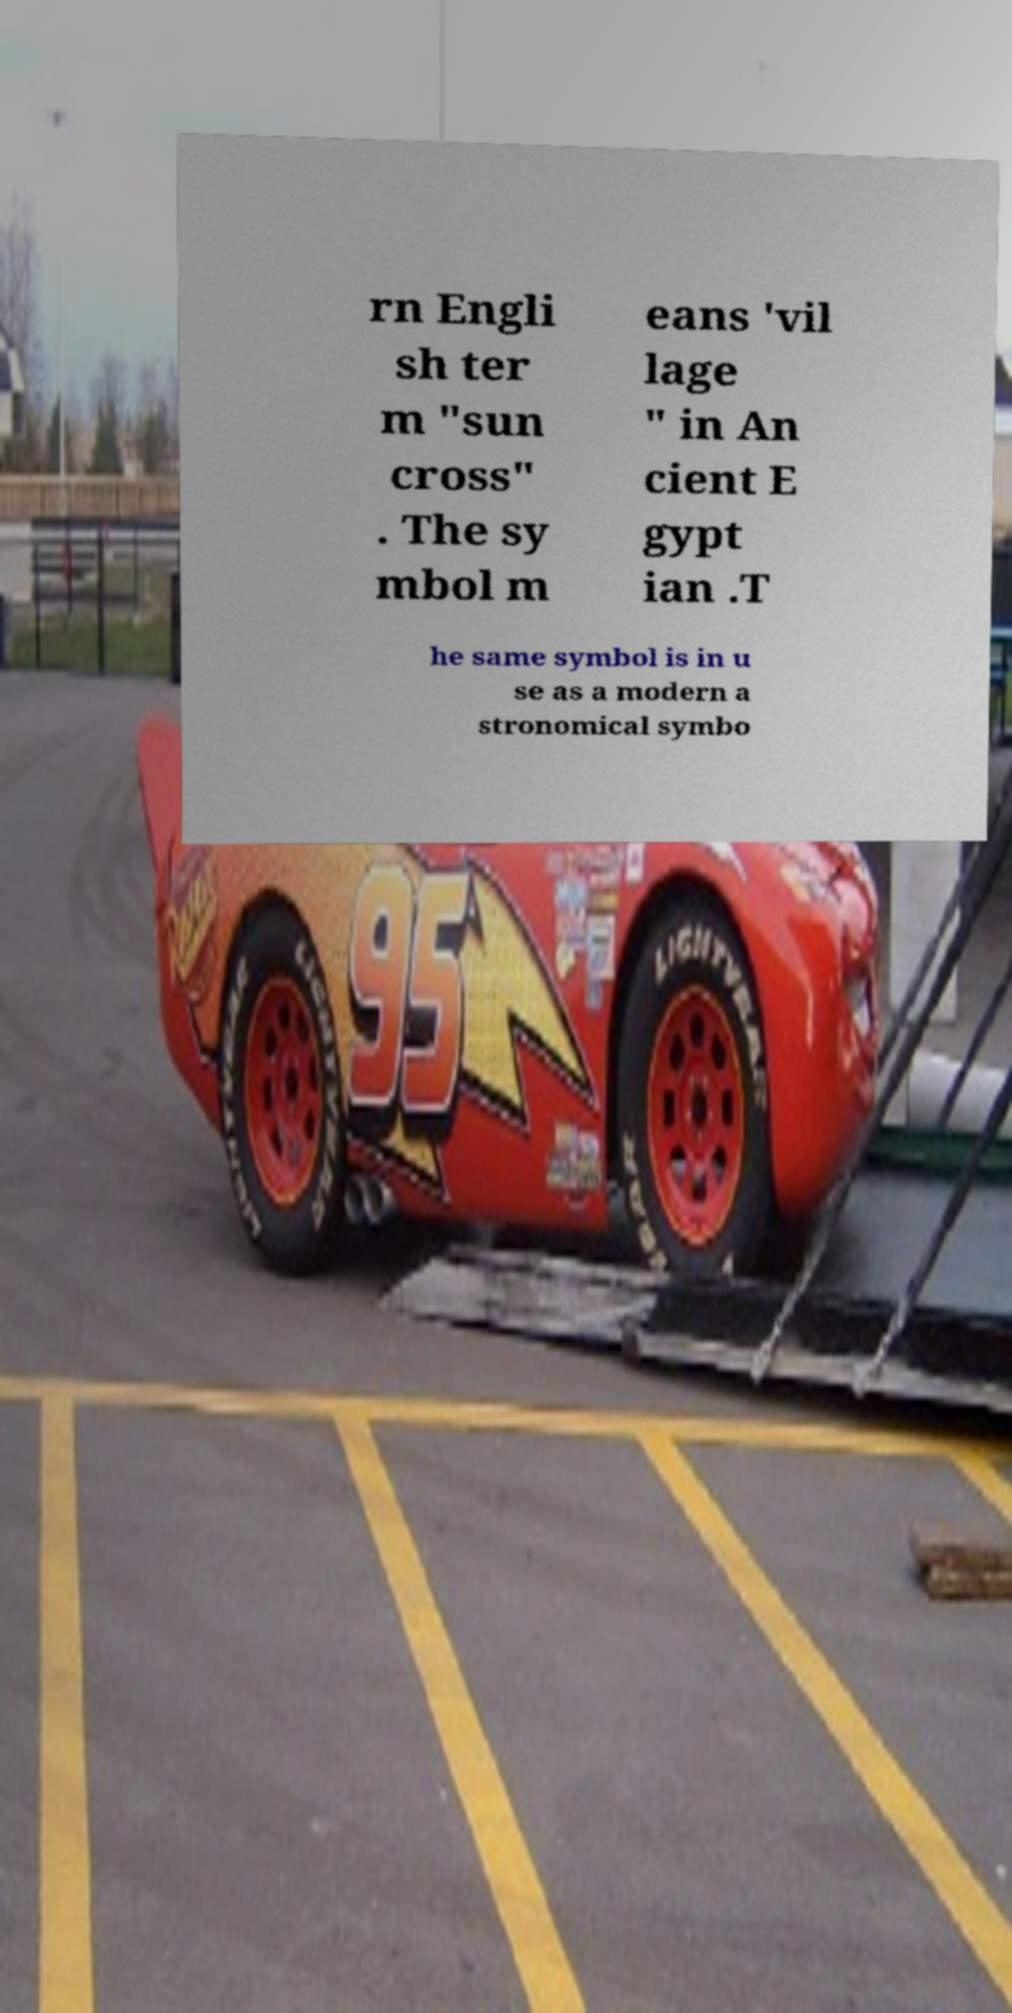Could you extract and type out the text from this image? rn Engli sh ter m "sun cross" . The sy mbol m eans 'vil lage " in An cient E gypt ian .T he same symbol is in u se as a modern a stronomical symbo 